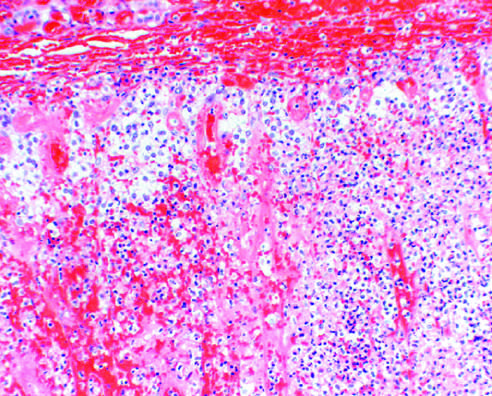s little residual cortical architecture discernible in this photomicrograph?
Answer the question using a single word or phrase. Yes 